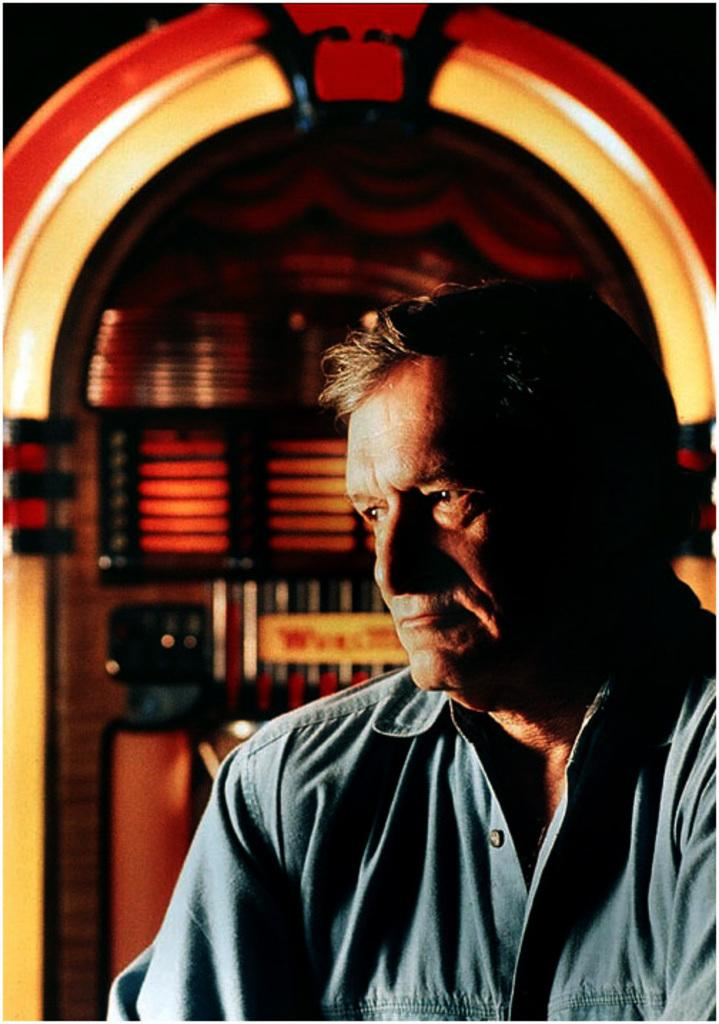Who is present in the image? There is a man in the image. What can be seen in the background of the image? There is a wall in the background of the image. What type of meat is the man preparing in the image? There is no indication of meat or any food preparation in the image; it only features a man and a wall in the background. 